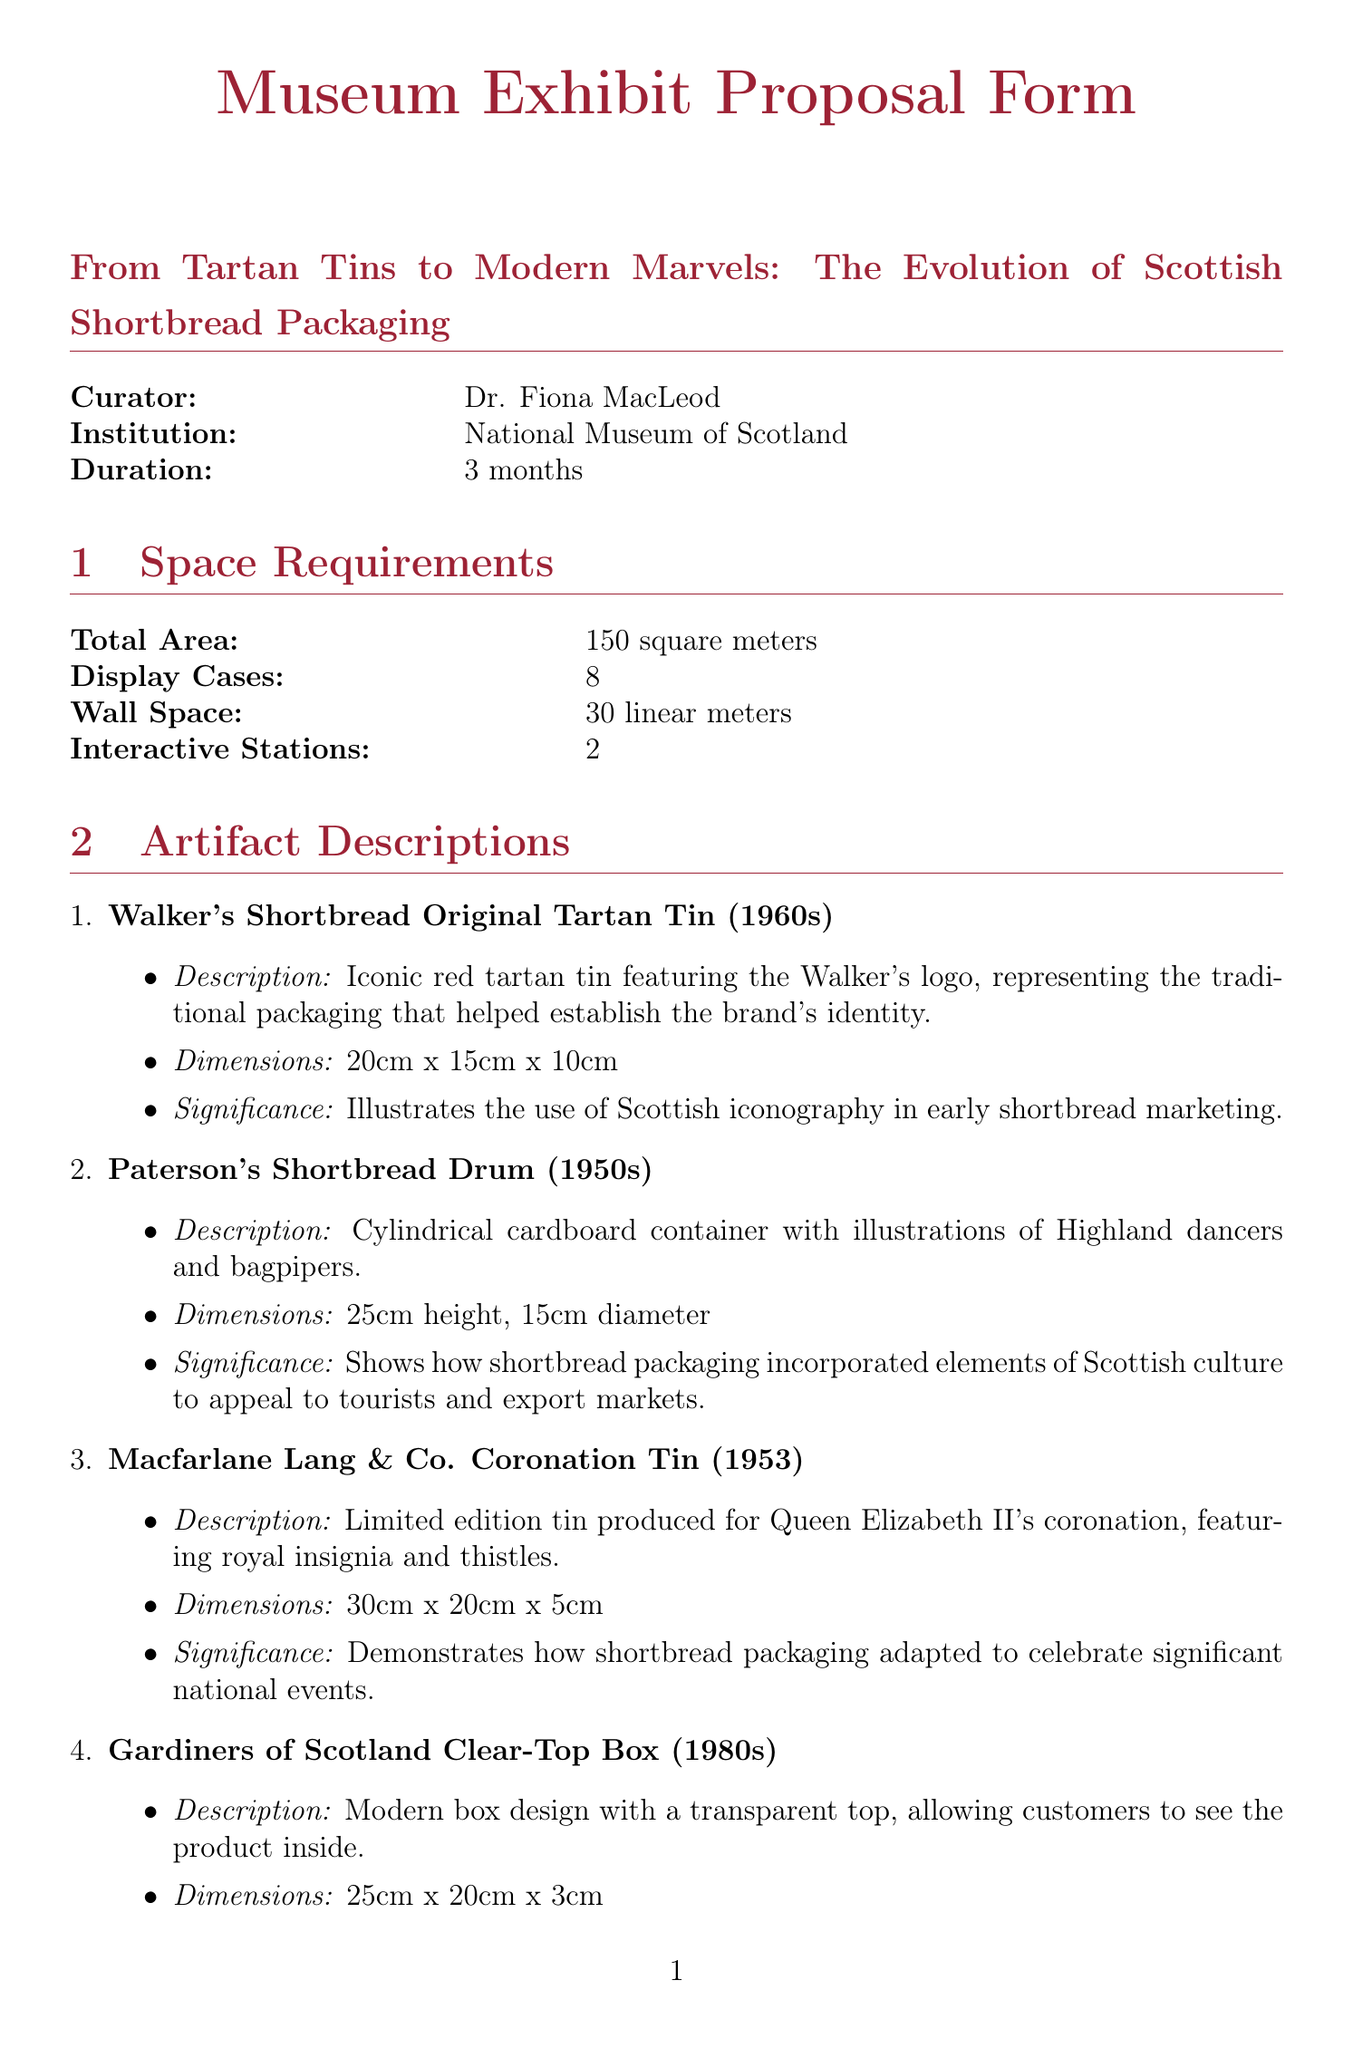what is the exhibit title? The exhibit title is explicitly stated at the beginning of the document as "From Tartan Tins to Modern Marvels: The Evolution of Scottish Shortbread Packaging."
Answer: From Tartan Tins to Modern Marvels: The Evolution of Scottish Shortbread Packaging who is the curator of the exhibit? The document clearly specifies that the curator of the exhibit is Dr. Fiona MacLeod.
Answer: Dr. Fiona MacLeod how long will the exhibit run? The duration of the exhibit is mentioned as "3 months."
Answer: 3 months what is the total area required for the exhibit? The document lists the total area requirements needed for the exhibit, stating "150 square meters."
Answer: 150 square meters what is one artifact from the 1950s in the exhibit? The document provides specific details about several artifacts, including "Paterson's Shortbread Drum (1950s)."
Answer: Paterson's Shortbread Drum (1950s) what interactive element requires the most wall space? The interactive element with the highest wall space requirement is specified in the document as "Shortbread Packaging Timeline," which requires "6 linear meters of wall space."
Answer: Shortbread Packaging Timeline which industry professionals is the target audience for this exhibit? The document lists various target audiences, specifying "Food industry professionals" as one of them.
Answer: Food industry professionals what is one proposed marketing strategy mentioned in the document? The document mentions multiple marketing strategies, including "Collaboration with Scottish shortbread manufacturers for promotional events."
Answer: Collaboration with Scottish shortbread manufacturers for promotional events what is the significance of Walker's Shortbread Original Tartan Tin? The document provides a concise significance statement for each artifact, stating that it "illustrates the use of Scottish iconography in early shortbread marketing."
Answer: illustrates the use of Scottish iconography in early shortbread marketing 